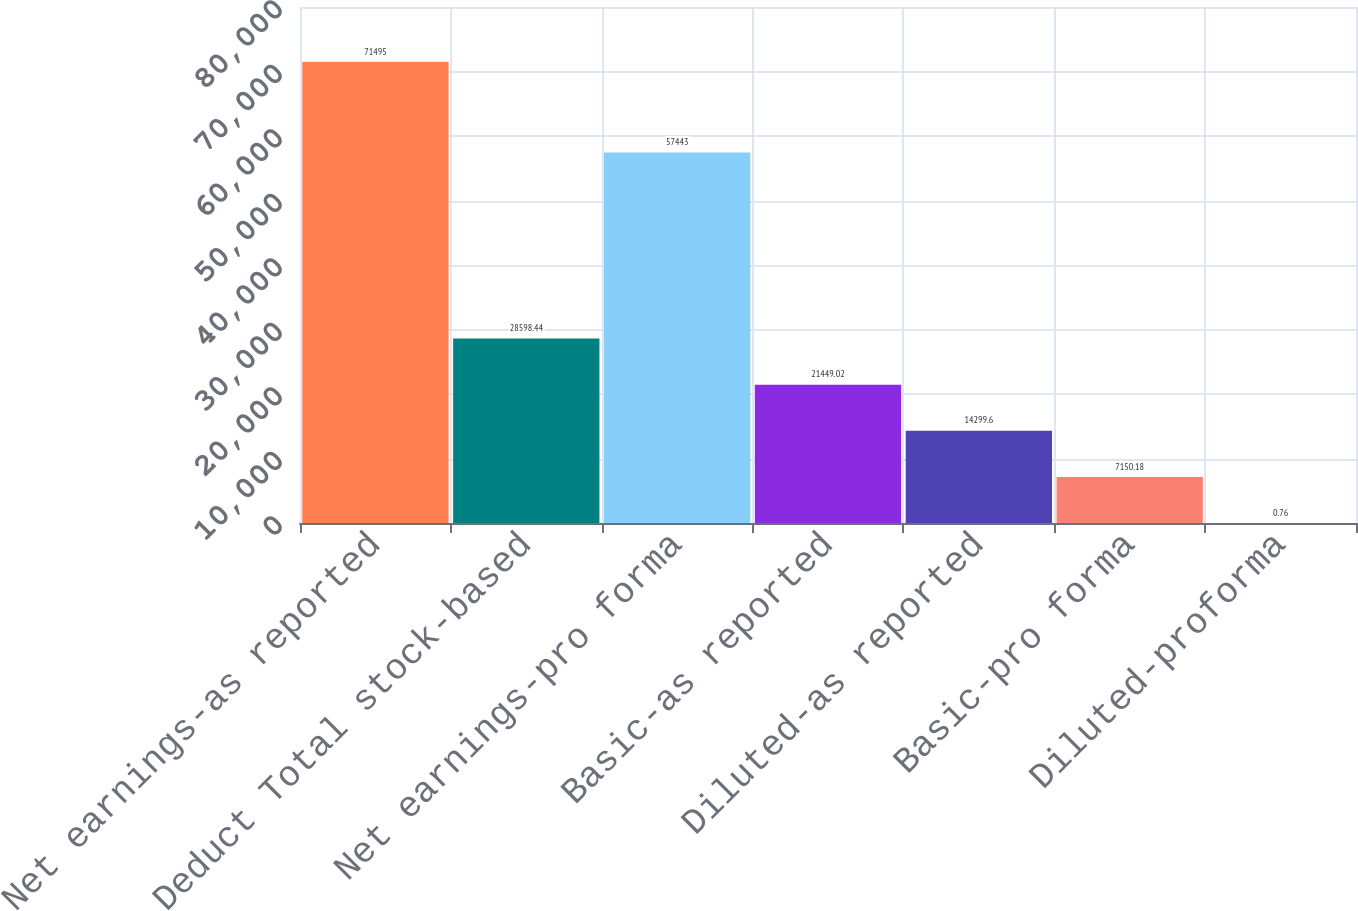<chart> <loc_0><loc_0><loc_500><loc_500><bar_chart><fcel>Net earnings-as reported<fcel>Deduct Total stock-based<fcel>Net earnings-pro forma<fcel>Basic-as reported<fcel>Diluted-as reported<fcel>Basic-pro forma<fcel>Diluted-proforma<nl><fcel>71495<fcel>28598.4<fcel>57443<fcel>21449<fcel>14299.6<fcel>7150.18<fcel>0.76<nl></chart> 